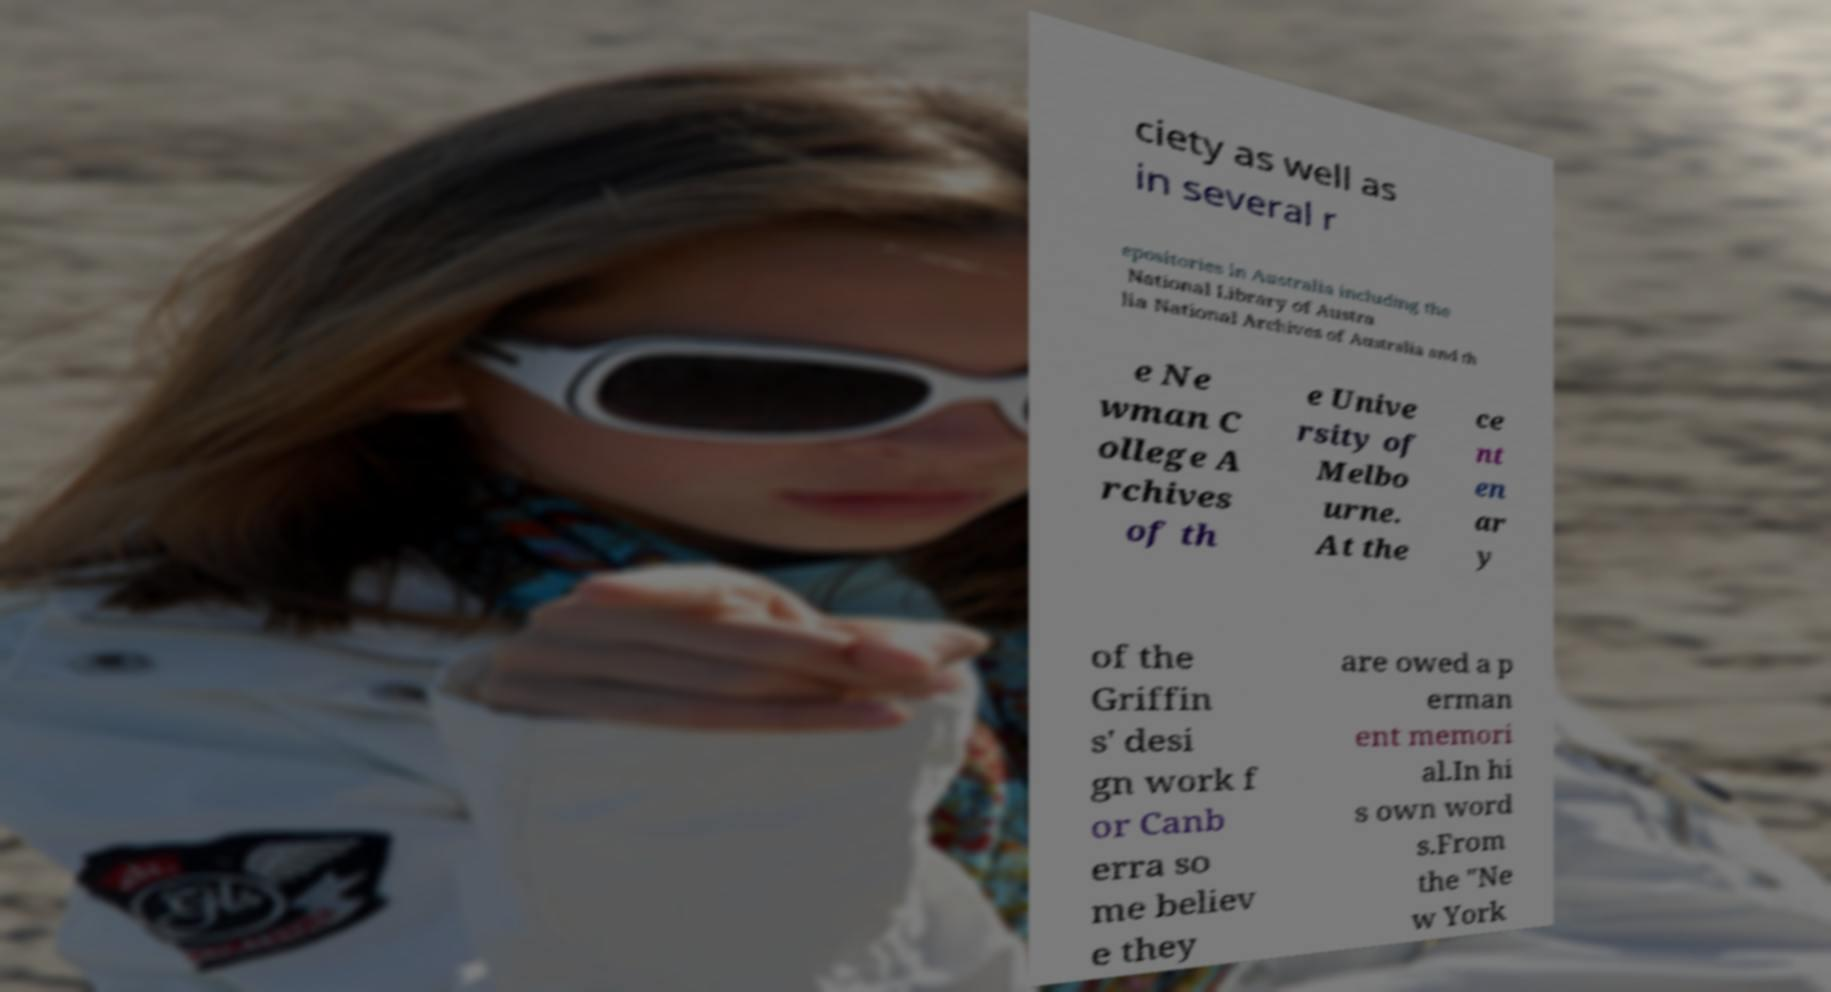Please identify and transcribe the text found in this image. ciety as well as in several r epositories in Australia including the National Library of Austra lia National Archives of Australia and th e Ne wman C ollege A rchives of th e Unive rsity of Melbo urne. At the ce nt en ar y of the Griffin s' desi gn work f or Canb erra so me believ e they are owed a p erman ent memori al.In hi s own word s.From the "Ne w York 